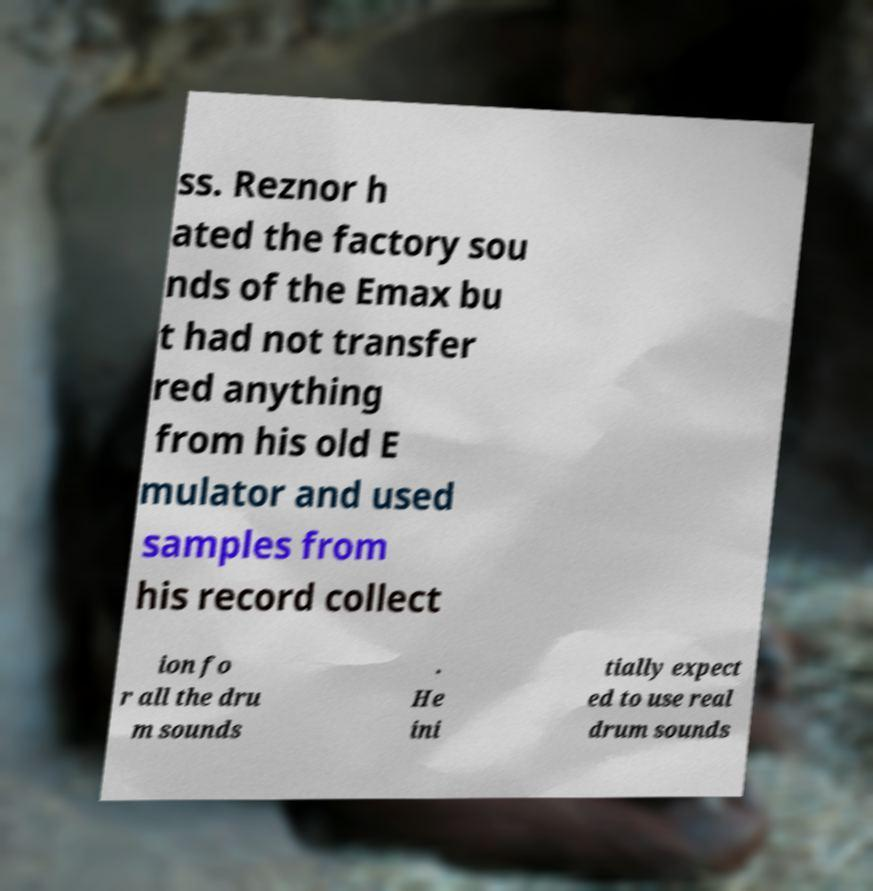What messages or text are displayed in this image? I need them in a readable, typed format. ss. Reznor h ated the factory sou nds of the Emax bu t had not transfer red anything from his old E mulator and used samples from his record collect ion fo r all the dru m sounds . He ini tially expect ed to use real drum sounds 